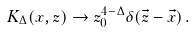<formula> <loc_0><loc_0><loc_500><loc_500>K _ { \Delta } ( x , z ) \rightarrow z _ { 0 } ^ { 4 - \Delta } \delta ( \vec { z } - \vec { x } ) \, .</formula> 